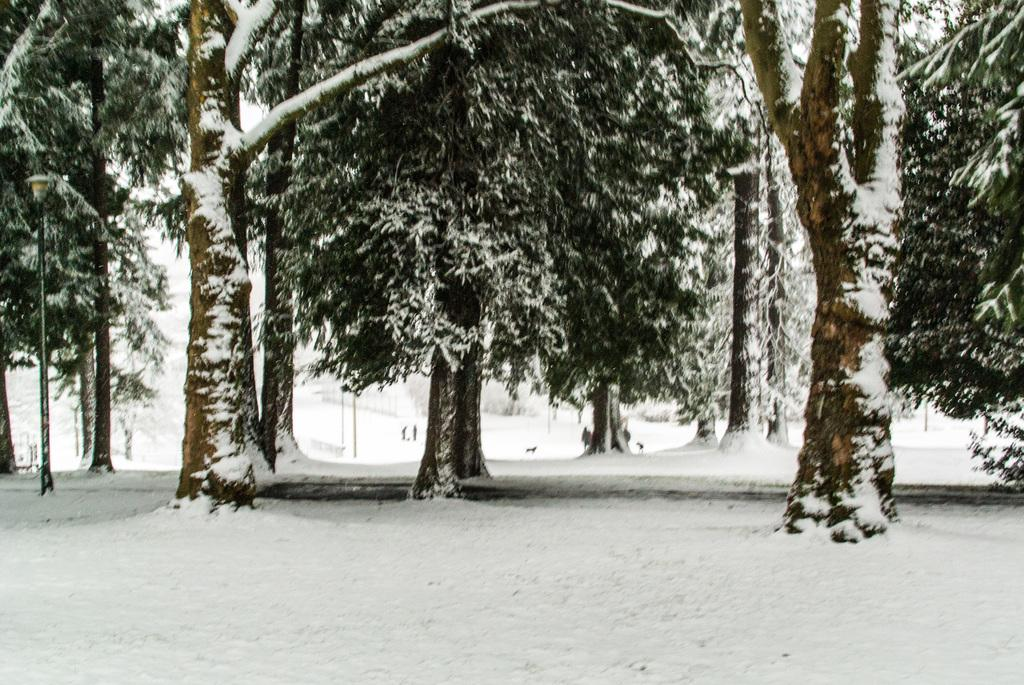What is the main feature of the landscape in the image? There is white snow in the image. What can be seen in the background of the image? There are trees in the background of the image. How are the trees affected by the snow? The trees have snow on them. How many people are present in the image? There are two persons in the image. What type of dress is the snail wearing in the image? There is no snail present in the image, and therefore no dress can be observed. 